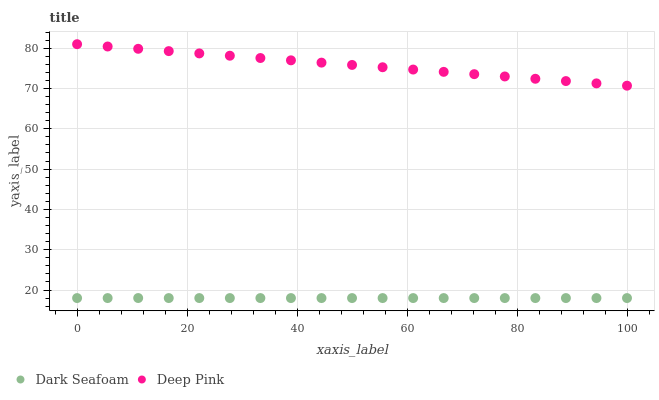Does Dark Seafoam have the minimum area under the curve?
Answer yes or no. Yes. Does Deep Pink have the maximum area under the curve?
Answer yes or no. Yes. Does Deep Pink have the minimum area under the curve?
Answer yes or no. No. Is Deep Pink the smoothest?
Answer yes or no. Yes. Is Dark Seafoam the roughest?
Answer yes or no. Yes. Is Deep Pink the roughest?
Answer yes or no. No. Does Dark Seafoam have the lowest value?
Answer yes or no. Yes. Does Deep Pink have the lowest value?
Answer yes or no. No. Does Deep Pink have the highest value?
Answer yes or no. Yes. Is Dark Seafoam less than Deep Pink?
Answer yes or no. Yes. Is Deep Pink greater than Dark Seafoam?
Answer yes or no. Yes. Does Dark Seafoam intersect Deep Pink?
Answer yes or no. No. 